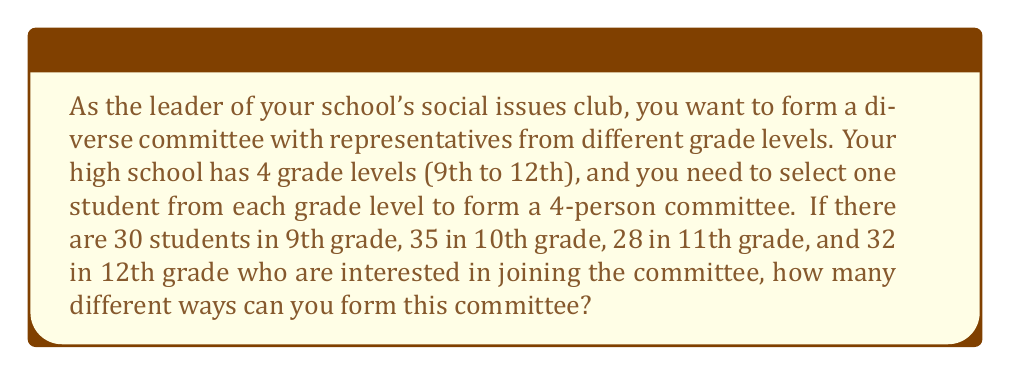Help me with this question. Let's approach this step-by-step:

1) We need to select one student from each grade level. This means we're dealing with independent selections from each grade.

2) For each grade level:
   - 9th grade: We need to choose 1 student out of 30
   - 10th grade: We need to choose 1 student out of 35
   - 11th grade: We need to choose 1 student out of 28
   - 12th grade: We need to choose 1 student out of 32

3) The number of ways to choose 1 student out of n students is simply n, as there are n possible choices.

4) Since we're making independent selections from each grade, we multiply the number of choices for each grade:

   $$ \text{Total ways} = 30 \times 35 \times 28 \times 32 $$

5) Let's calculate this:
   $$ 30 \times 35 \times 28 \times 32 = 940,800 $$

Therefore, there are 940,800 different ways to form the committee.
Answer: 940,800 